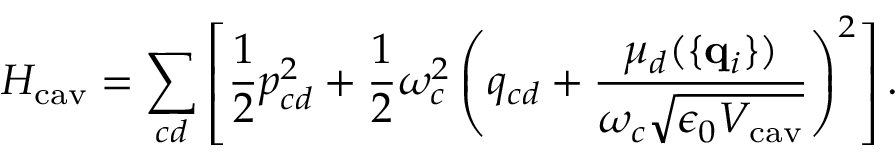<formula> <loc_0><loc_0><loc_500><loc_500>H _ { c a v } = \sum _ { c d } \left [ { \frac { 1 } { 2 } } { p } _ { c d } ^ { 2 } + { \frac { 1 } { 2 } } \omega _ { c } ^ { 2 } \left ( { q } _ { c d } + { \frac { \mu _ { d } ( \{ { q } _ { i } \} ) } { \omega _ { c } \sqrt { \epsilon _ { 0 } V _ { c a v } } } } \right ) ^ { 2 } \right ] .</formula> 